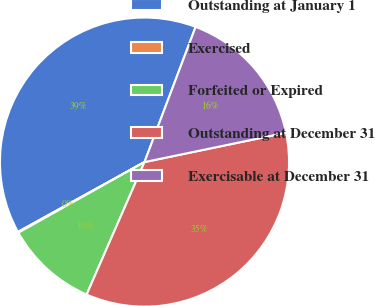<chart> <loc_0><loc_0><loc_500><loc_500><pie_chart><fcel>Outstanding at January 1<fcel>Exercised<fcel>Forfeited or Expired<fcel>Outstanding at December 31<fcel>Exercisable at December 31<nl><fcel>38.78%<fcel>0.1%<fcel>10.32%<fcel>34.81%<fcel>15.99%<nl></chart> 